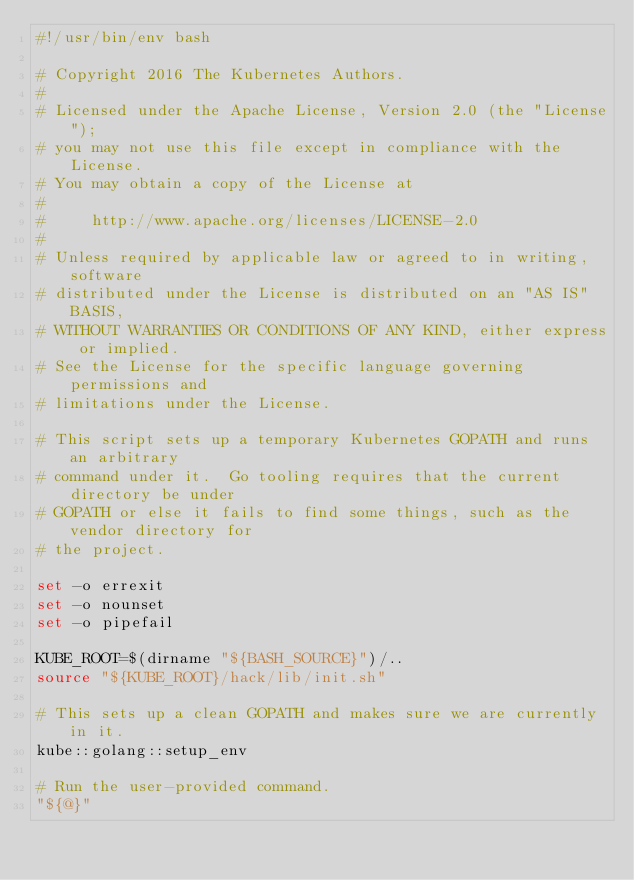<code> <loc_0><loc_0><loc_500><loc_500><_Bash_>#!/usr/bin/env bash

# Copyright 2016 The Kubernetes Authors.
#
# Licensed under the Apache License, Version 2.0 (the "License");
# you may not use this file except in compliance with the License.
# You may obtain a copy of the License at
#
#     http://www.apache.org/licenses/LICENSE-2.0
#
# Unless required by applicable law or agreed to in writing, software
# distributed under the License is distributed on an "AS IS" BASIS,
# WITHOUT WARRANTIES OR CONDITIONS OF ANY KIND, either express or implied.
# See the License for the specific language governing permissions and
# limitations under the License.

# This script sets up a temporary Kubernetes GOPATH and runs an arbitrary
# command under it.  Go tooling requires that the current directory be under
# GOPATH or else it fails to find some things, such as the vendor directory for
# the project.

set -o errexit
set -o nounset
set -o pipefail

KUBE_ROOT=$(dirname "${BASH_SOURCE}")/..
source "${KUBE_ROOT}/hack/lib/init.sh"

# This sets up a clean GOPATH and makes sure we are currently in it.
kube::golang::setup_env

# Run the user-provided command.
"${@}"
</code> 